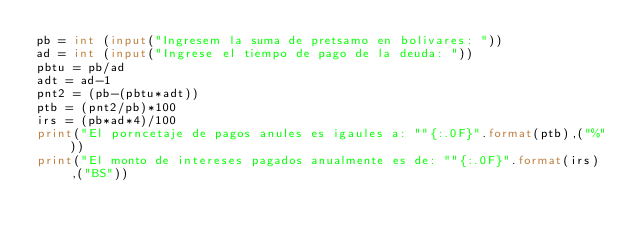<code> <loc_0><loc_0><loc_500><loc_500><_Python_>pb = int (input("Ingresem la suma de pretsamo en bolivares: "))
ad = int (input("Ingrese el tiempo de pago de la deuda: "))
pbtu = pb/ad
adt = ad-1
pnt2 = (pb-(pbtu*adt))
ptb = (pnt2/pb)*100
irs = (pb*ad*4)/100
print("El porncetaje de pagos anules es igaules a: ""{:.0F}".format(ptb),("%"))
print("El monto de intereses pagados anualmente es de: ""{:.0F}".format(irs),("BS"))</code> 